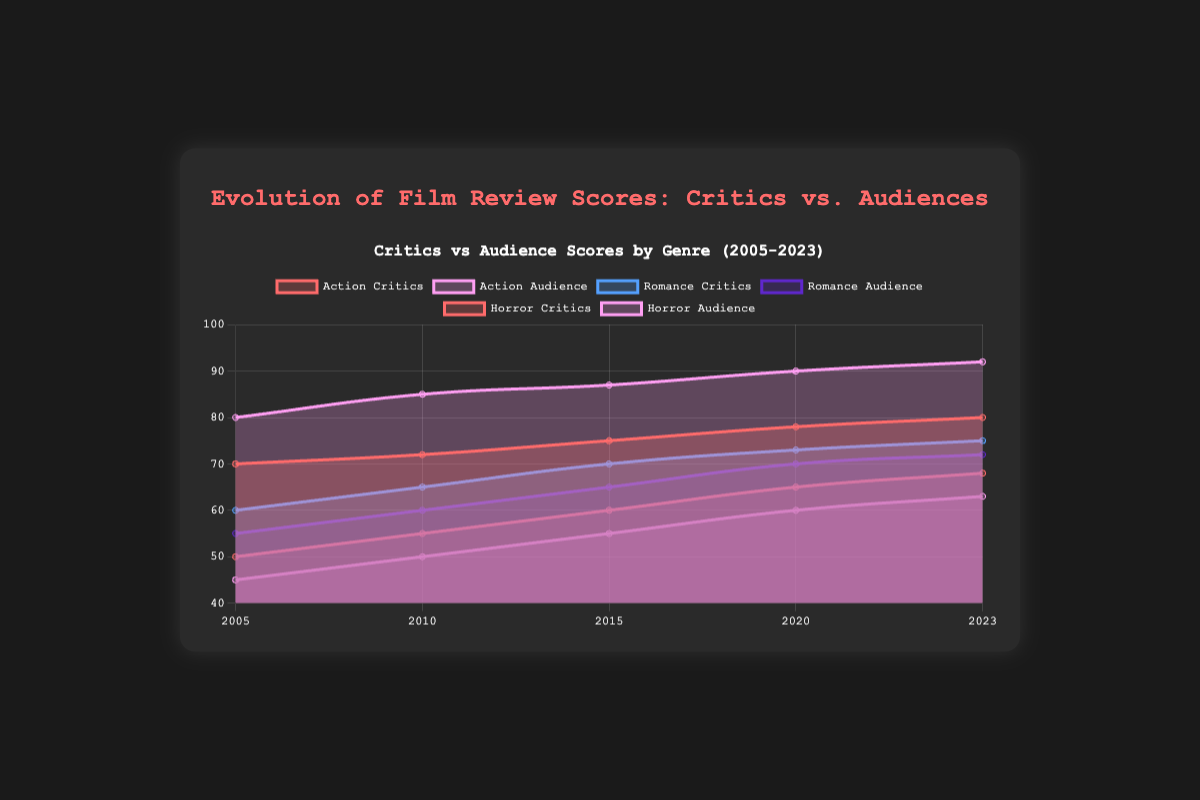What is the trend in critics' scores for Action movies from 2005 to 2023? Look at the curve representing critics' scores for Action movies. Observe the direction and pattern of the line plot. It shows an increasing trend from 70 in 2005 to 80 in 2023.
Answer: Increasing Which year had the largest difference between critics' and audience scores for Romance movies? Calculate the differences between critics' and audience scores for each year for Romance movies. The differences are: 2005: 5, 2010: 5, 2015: 5, 2020: 3, 2023: 3. The year 2005 has the largest difference (60 critics, 55 audience = 5).
Answer: 2005 How does the audience score trend for Horror movies compare to that of Romance movies from 2005 to 2023? Observe the line plots of audience scores for both Horror and Romance movies. Both show an overall increasing trend, but the audience score for Horror movies remains consistently lower than for Romance throughout the years.
Answer: Both increasing, but Horror remains lower What was the critics' score for Action movies in 2015? Directly look at the point on the curve representing the critics' scores for Action movies in 2015. The score is marked at 75.
Answer: 75 Calculate the average critics' score for Romance movies across all years. Find the critics' scores for Romance movies for each year (60, 65, 70, 73, 75), sum them up (60+65+70+73+75=343), and then divide by the number of years (5). The result is 343/5 = 68.6.
Answer: 68.6 Which genre generally received higher scores from audiences than critics over the years? Compare the overall positional trends of audience and critics' scores for each genre. Action movies consistently show higher audience scores compared to critics' scores throughout all the years.
Answer: Action Identify the genre with the smallest increase in critics' scores from 2005 to 2023. Calculate the difference in critics' scores between 2023 and 2005 for each genre. Action: 80-70=10, Romance: 75-60=15, Horror: 68-50=18. The smallest increase is seen in Action movies with a 10-point rise.
Answer: Action What is the trend of the audience score for Action movies from 2010 to 2023? Observe the line plot segment of Action audience scores between 2010 and 2023. The scores steadily increase from 85 in 2010 to 92 in 2023.
Answer: Increasing How do the critics' scores for Horror movies in 2010 compare to their scores in 2023? Look at the critics' scores for Horror movies in 2010 and 2023. In 2010, the score is 55, and in 2023, the score is 68. Therefore, the 2023 score is higher.
Answer: Higher in 2023 What is the general trend for Romance movies' audience scores from 2005 to 2023? Observe the line plot representing Romance audience scores from 2005 to 2023. The scores increase from 55 in 2005 to 72 in 2023, indicating a general increasing trend.
Answer: Increasing 